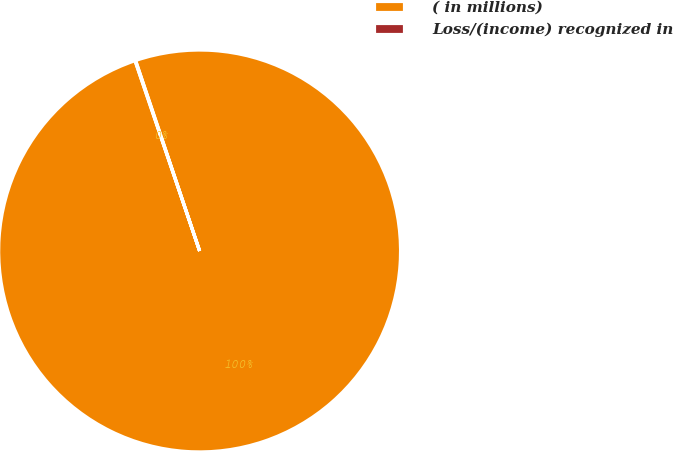<chart> <loc_0><loc_0><loc_500><loc_500><pie_chart><fcel>( in millions)<fcel>Loss/(income) recognized in<nl><fcel>99.95%<fcel>0.05%<nl></chart> 